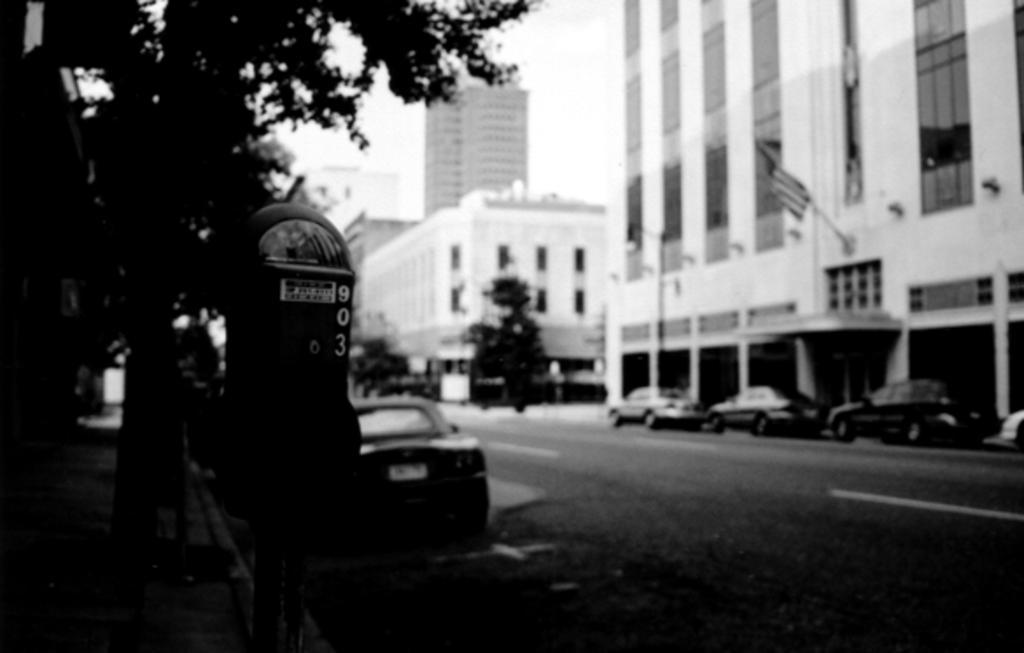Please provide a concise description of this image. This is a black and white picture. This picture is clicked outside the city. At the bottom, we see the road. On the right side, we see the cars parked on the road. Beside that, we see the trees, flag and the buildings. On the left side, we see a parking meter, trees and a building. Beside that, we see a car parked on the road. In the background, we see the trees, buildings and the sky. 